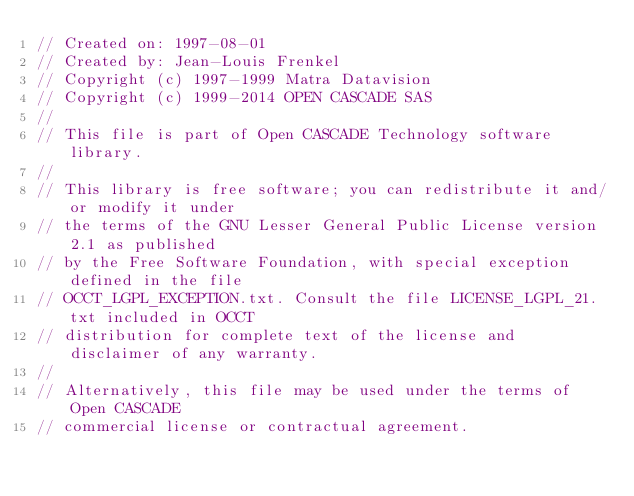<code> <loc_0><loc_0><loc_500><loc_500><_C++_>// Created on: 1997-08-01
// Created by: Jean-Louis Frenkel
// Copyright (c) 1997-1999 Matra Datavision
// Copyright (c) 1999-2014 OPEN CASCADE SAS
//
// This file is part of Open CASCADE Technology software library.
//
// This library is free software; you can redistribute it and/or modify it under
// the terms of the GNU Lesser General Public License version 2.1 as published
// by the Free Software Foundation, with special exception defined in the file
// OCCT_LGPL_EXCEPTION.txt. Consult the file LICENSE_LGPL_21.txt included in OCCT
// distribution for complete text of the license and disclaimer of any warranty.
//
// Alternatively, this file may be used under the terms of Open CASCADE
// commercial license or contractual agreement.
</code> 